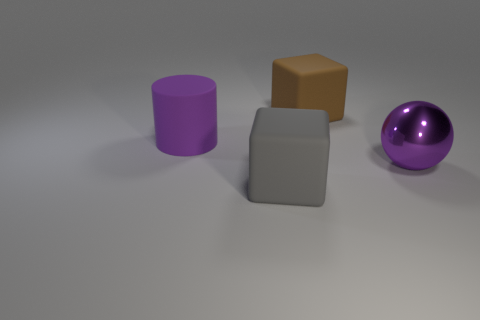Add 1 purple shiny balls. How many objects exist? 5 Subtract all cylinders. How many objects are left? 3 Subtract 0 yellow cylinders. How many objects are left? 4 Subtract all big gray rubber things. Subtract all yellow things. How many objects are left? 3 Add 4 brown rubber things. How many brown rubber things are left? 5 Add 4 gray blocks. How many gray blocks exist? 5 